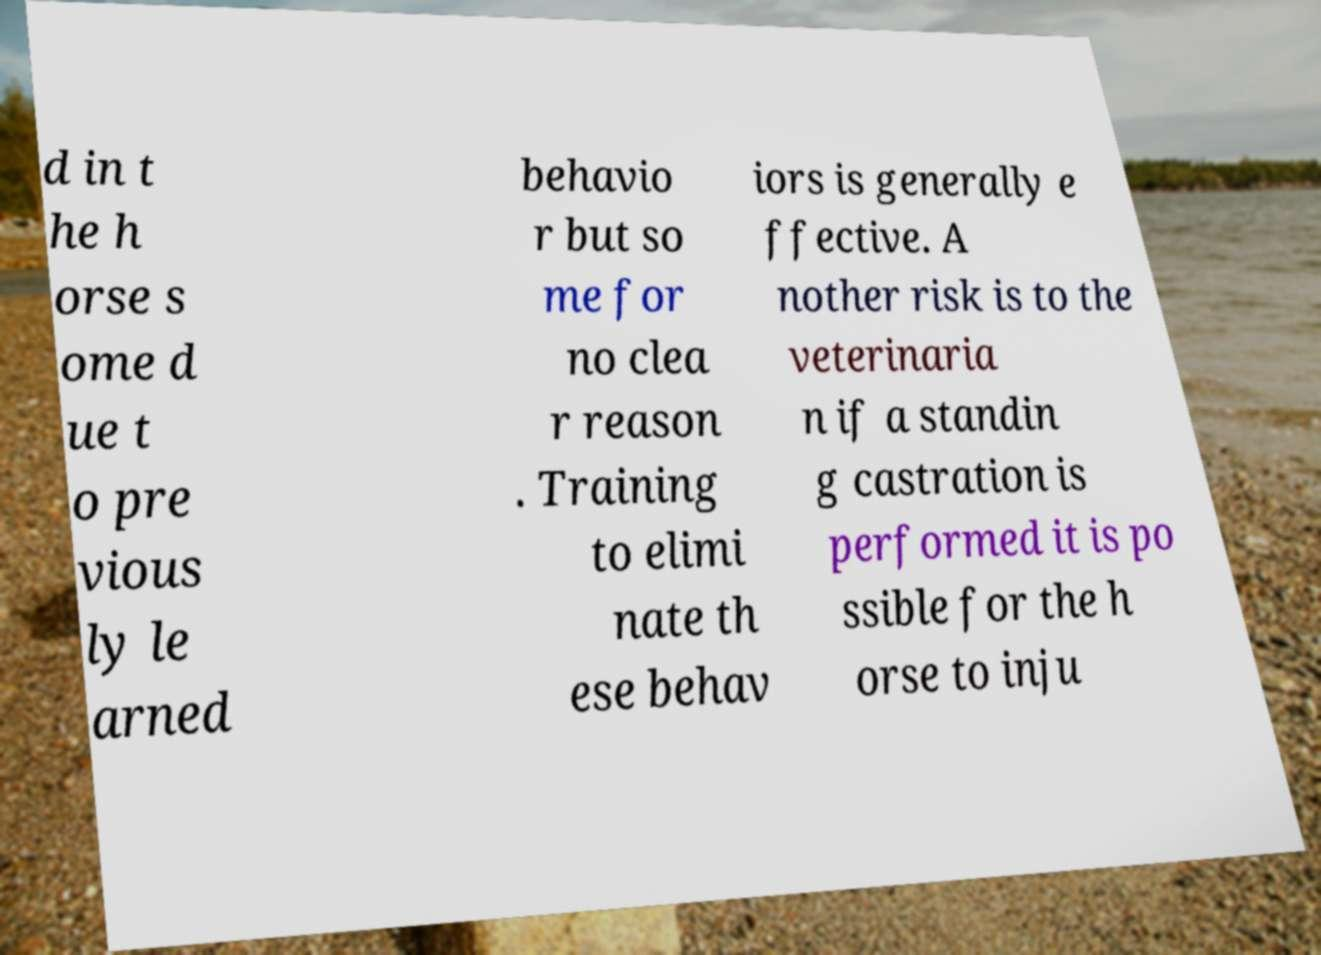What messages or text are displayed in this image? I need them in a readable, typed format. d in t he h orse s ome d ue t o pre vious ly le arned behavio r but so me for no clea r reason . Training to elimi nate th ese behav iors is generally e ffective. A nother risk is to the veterinaria n if a standin g castration is performed it is po ssible for the h orse to inju 